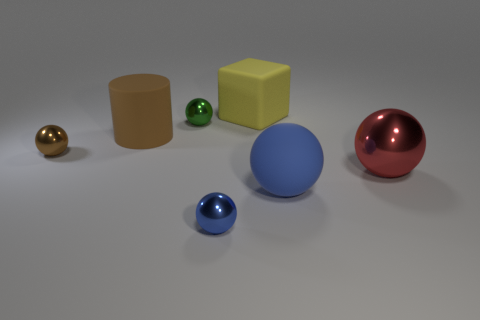Is there a sense of harmony or contrast in the arrangement of these objects? The arrangement of the objects presents a visual harmony through the balanced distribution of shapes and colors, creating a pleasing aesthetic. Yet, there's an element of contrast as well, with the varied colors and sizes of the objects, contrasting textures, and the difference between the simple geometric shapes. 